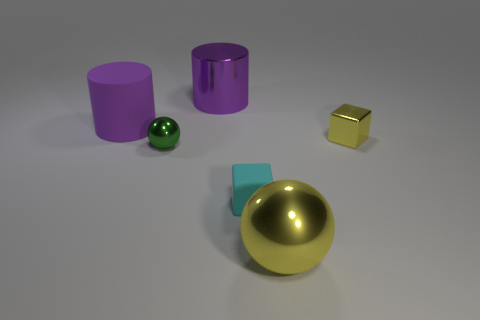Subtract 2 cylinders. How many cylinders are left? 0 Subtract all yellow balls. How many balls are left? 1 Add 2 metallic cylinders. How many objects exist? 8 Subtract all balls. How many objects are left? 4 Add 3 cyan metallic balls. How many cyan metallic balls exist? 3 Subtract 0 red blocks. How many objects are left? 6 Subtract all gray cylinders. Subtract all purple blocks. How many cylinders are left? 2 Subtract all blue cylinders. How many cyan cubes are left? 1 Subtract all yellow metal spheres. Subtract all yellow blocks. How many objects are left? 4 Add 3 big metallic balls. How many big metallic balls are left? 4 